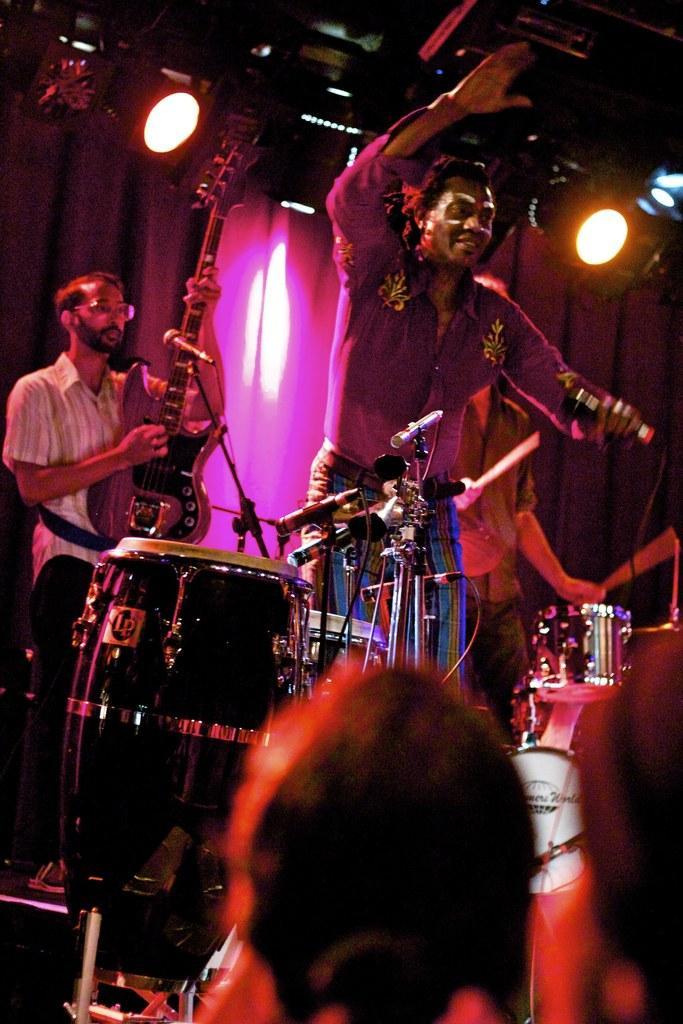Could you give a brief overview of what you see in this image? In this image there is a man in the middle who is standing with a mic in his hand. At the background there is another man who is playing the guitar with his hand. In front them there are drums and mic stand. There are crowd who are watching them on the stage. 